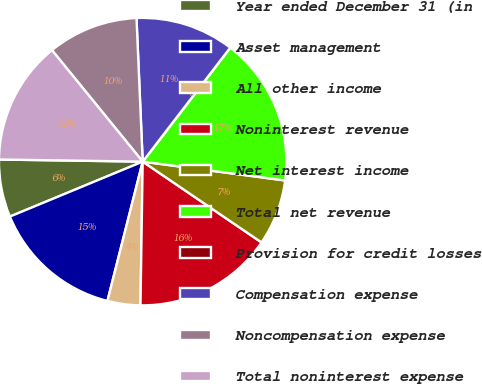Convert chart to OTSL. <chart><loc_0><loc_0><loc_500><loc_500><pie_chart><fcel>Year ended December 31 (in<fcel>Asset management<fcel>All other income<fcel>Noninterest revenue<fcel>Net interest income<fcel>Total net revenue<fcel>Provision for credit losses<fcel>Compensation expense<fcel>Noncompensation expense<fcel>Total noninterest expense<nl><fcel>6.48%<fcel>14.81%<fcel>3.7%<fcel>15.74%<fcel>7.41%<fcel>16.67%<fcel>0.0%<fcel>11.11%<fcel>10.19%<fcel>13.89%<nl></chart> 